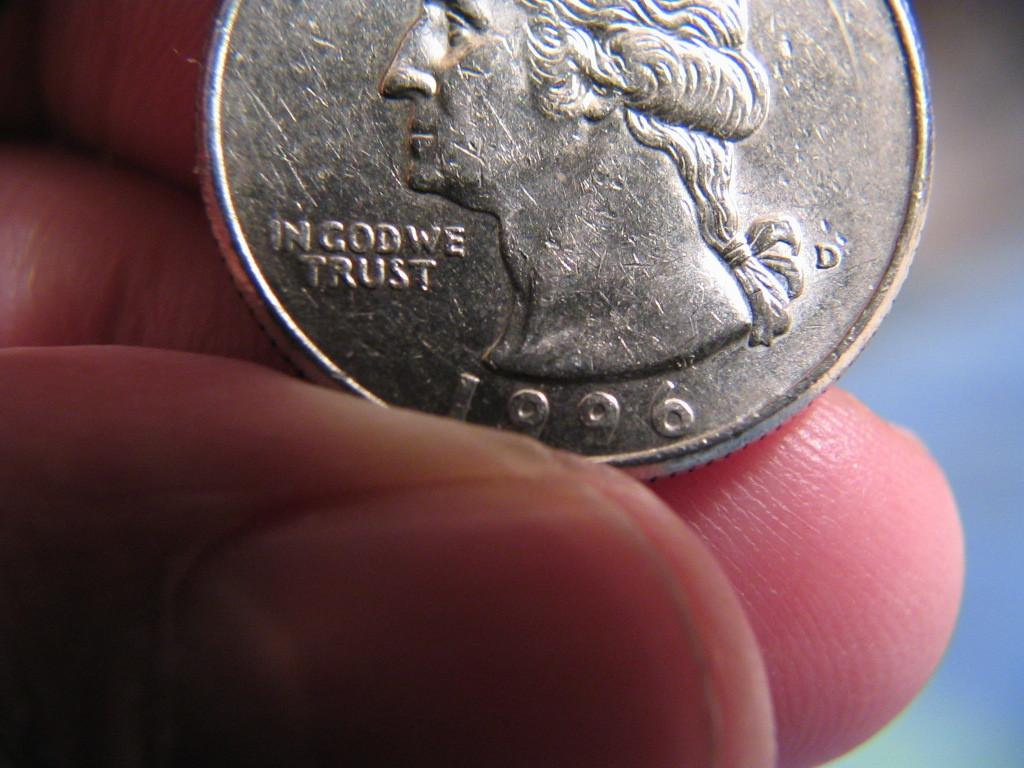<image>
Relay a brief, clear account of the picture shown. A person is holding a 1996 quarter that says, 'In God We Trust'. 